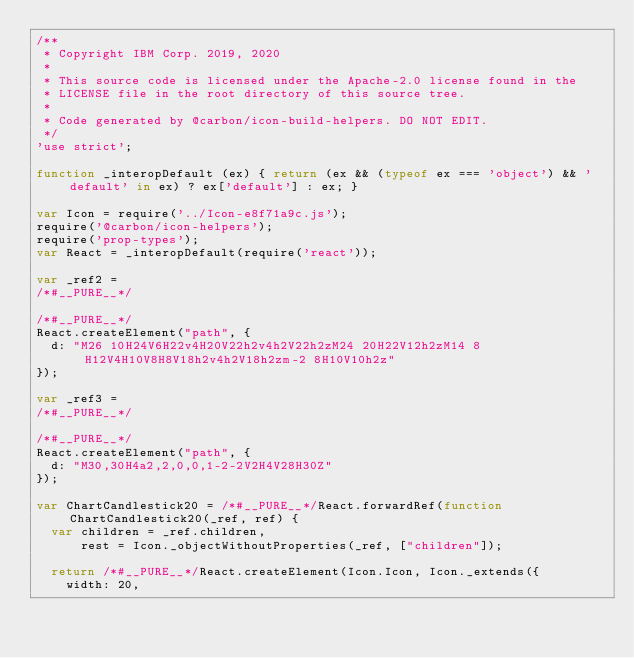Convert code to text. <code><loc_0><loc_0><loc_500><loc_500><_JavaScript_>/**
 * Copyright IBM Corp. 2019, 2020
 *
 * This source code is licensed under the Apache-2.0 license found in the
 * LICENSE file in the root directory of this source tree.
 *
 * Code generated by @carbon/icon-build-helpers. DO NOT EDIT.
 */
'use strict';

function _interopDefault (ex) { return (ex && (typeof ex === 'object') && 'default' in ex) ? ex['default'] : ex; }

var Icon = require('../Icon-e8f71a9c.js');
require('@carbon/icon-helpers');
require('prop-types');
var React = _interopDefault(require('react'));

var _ref2 =
/*#__PURE__*/

/*#__PURE__*/
React.createElement("path", {
  d: "M26 10H24V6H22v4H20V22h2v4h2V22h2zM24 20H22V12h2zM14 8H12V4H10V8H8V18h2v4h2V18h2zm-2 8H10V10h2z"
});

var _ref3 =
/*#__PURE__*/

/*#__PURE__*/
React.createElement("path", {
  d: "M30,30H4a2,2,0,0,1-2-2V2H4V28H30Z"
});

var ChartCandlestick20 = /*#__PURE__*/React.forwardRef(function ChartCandlestick20(_ref, ref) {
  var children = _ref.children,
      rest = Icon._objectWithoutProperties(_ref, ["children"]);

  return /*#__PURE__*/React.createElement(Icon.Icon, Icon._extends({
    width: 20,</code> 